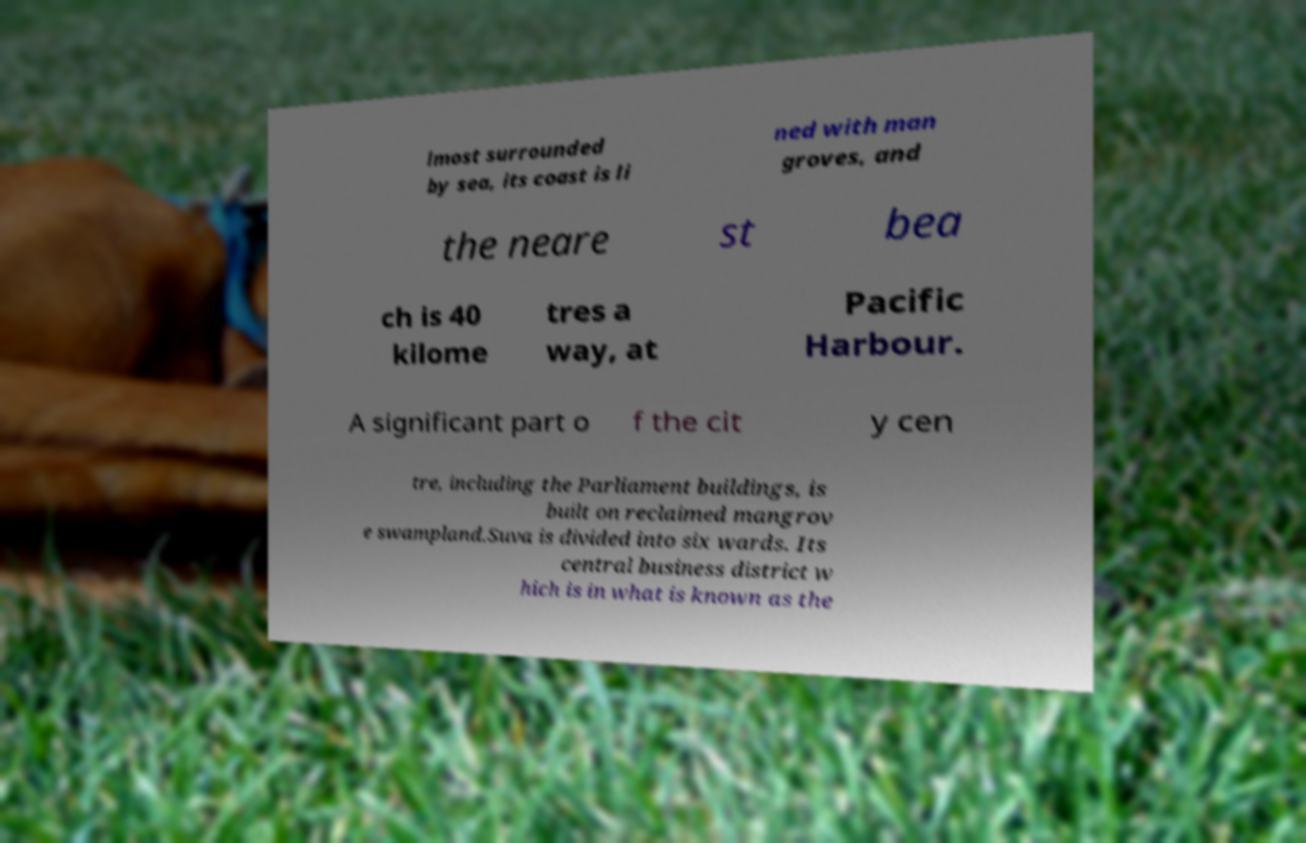For documentation purposes, I need the text within this image transcribed. Could you provide that? lmost surrounded by sea, its coast is li ned with man groves, and the neare st bea ch is 40 kilome tres a way, at Pacific Harbour. A significant part o f the cit y cen tre, including the Parliament buildings, is built on reclaimed mangrov e swampland.Suva is divided into six wards. Its central business district w hich is in what is known as the 